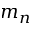<formula> <loc_0><loc_0><loc_500><loc_500>m _ { n }</formula> 